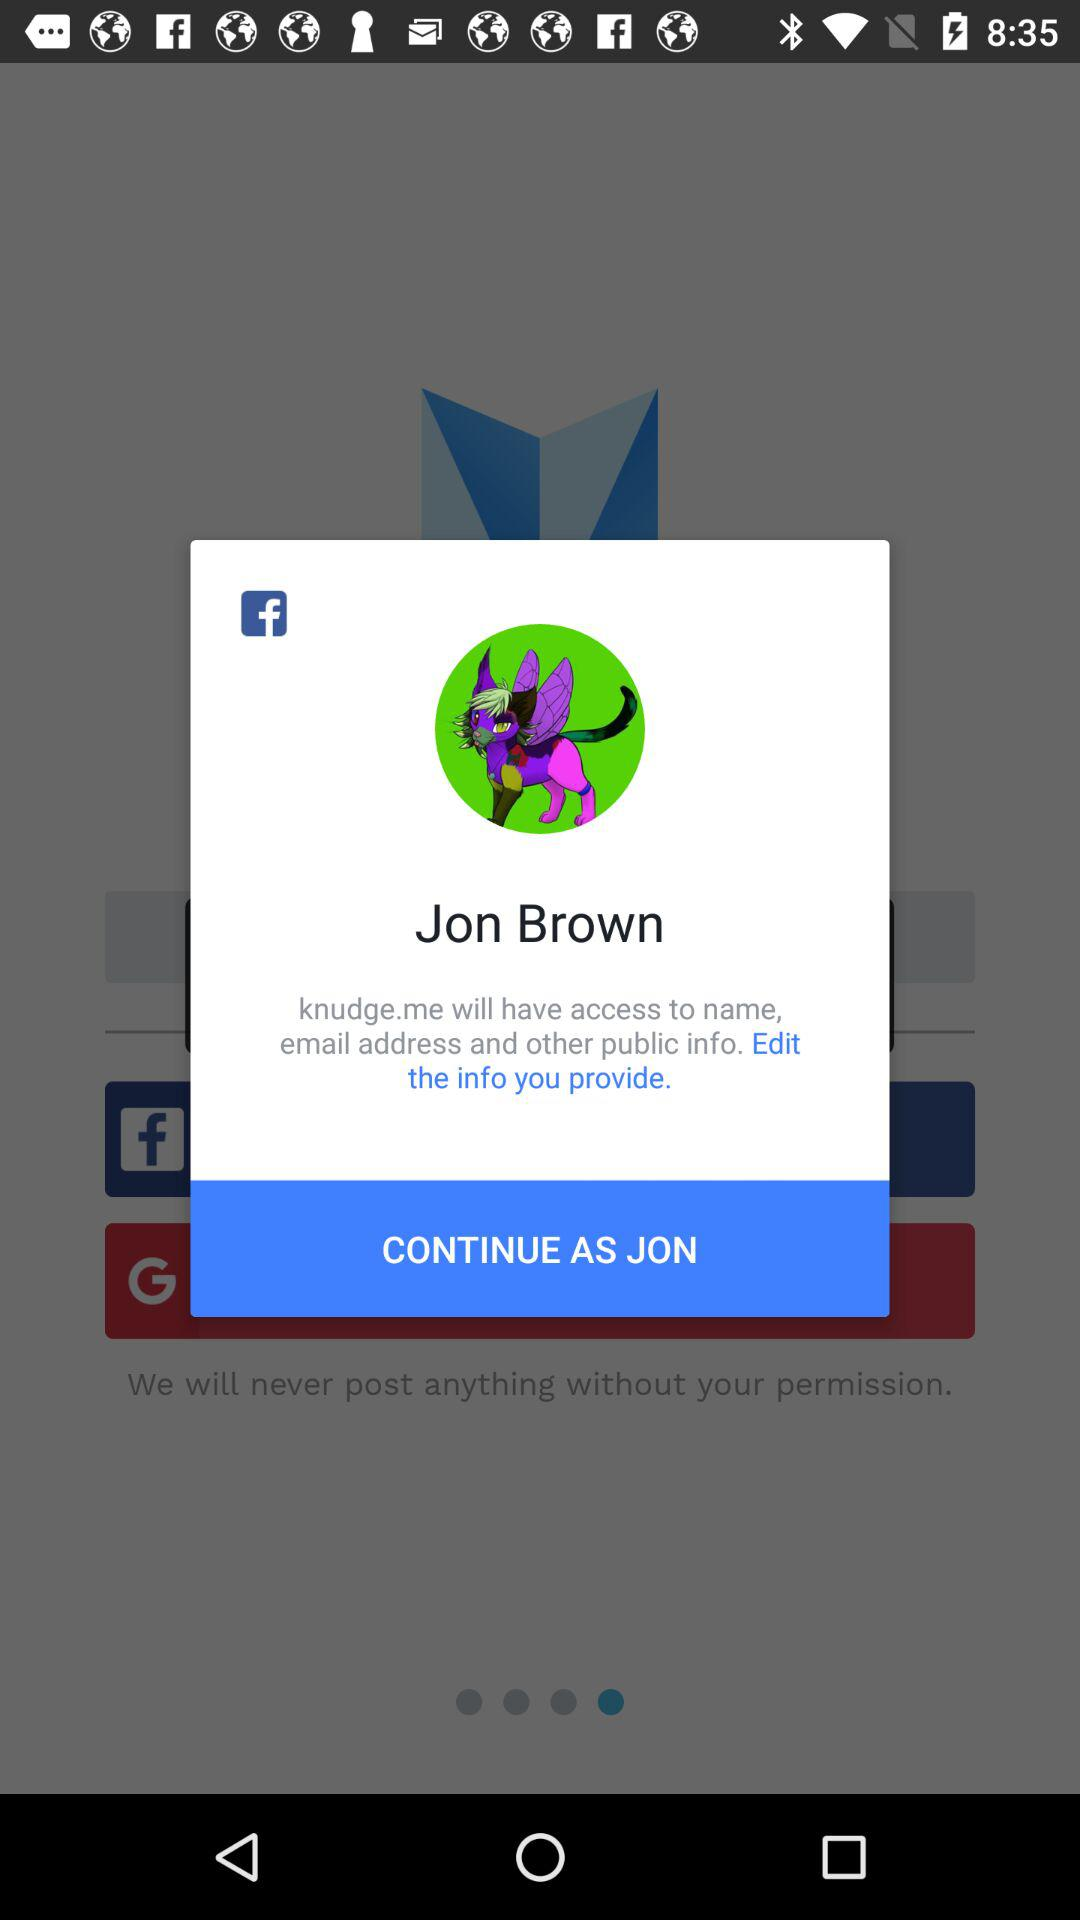What application is asking for permissions? The application asking for permission is "Knudge.me". 